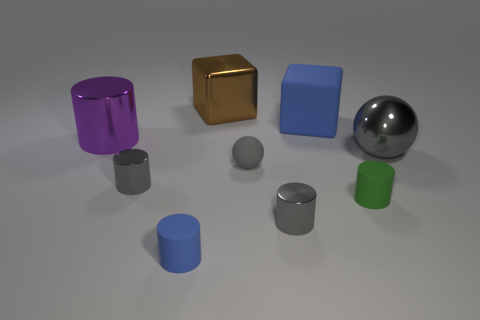Are there fewer big cyan metal blocks than big purple metallic cylinders?
Offer a terse response. Yes. Does the big blue thing have the same shape as the green thing?
Provide a succinct answer. No. What is the color of the large metallic cylinder?
Your answer should be very brief. Purple. How many other things are there of the same material as the big brown block?
Provide a succinct answer. 4. How many purple things are either metallic spheres or metal things?
Your answer should be very brief. 1. There is a blue matte thing that is in front of the big gray metal ball; is its shape the same as the blue object on the right side of the shiny cube?
Keep it short and to the point. No. There is a large cylinder; does it have the same color as the large thing that is right of the small green object?
Ensure brevity in your answer.  No. There is a tiny metal thing in front of the green matte thing; is it the same color as the big metallic sphere?
Provide a short and direct response. Yes. How many things are either tiny red cylinders or blue blocks left of the green thing?
Your answer should be compact. 1. What is the big thing that is in front of the brown metal block and on the left side of the gray matte object made of?
Your response must be concise. Metal. 